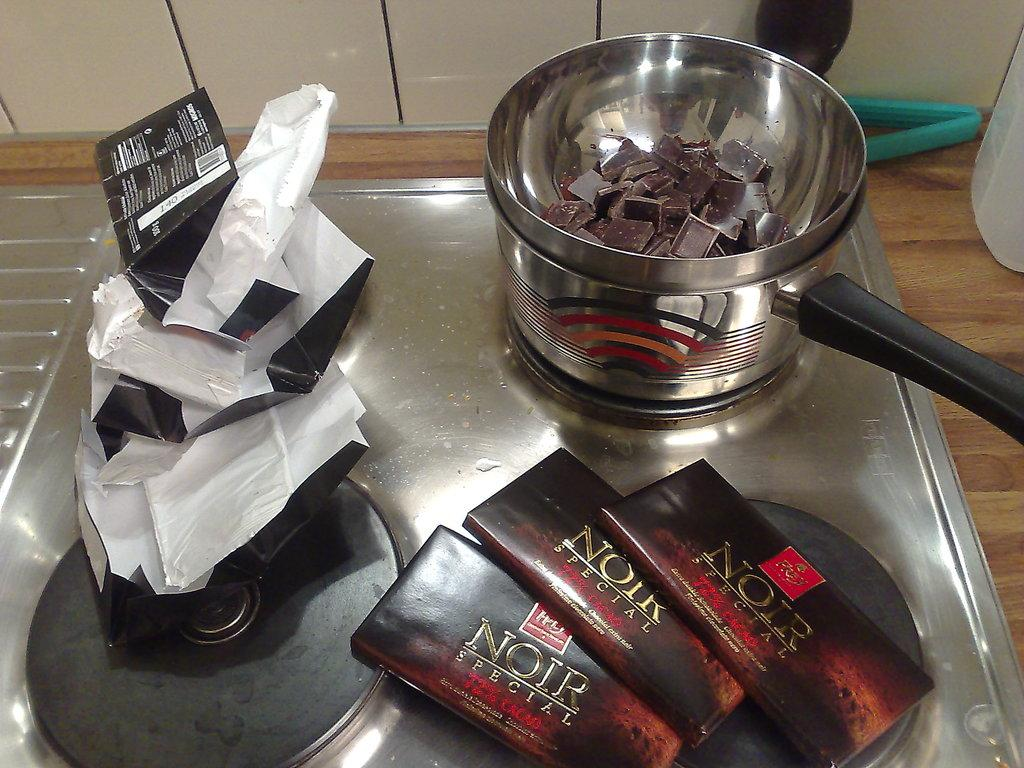<image>
Provide a brief description of the given image. A pan melts a broken up bar of Noir chocolate. 